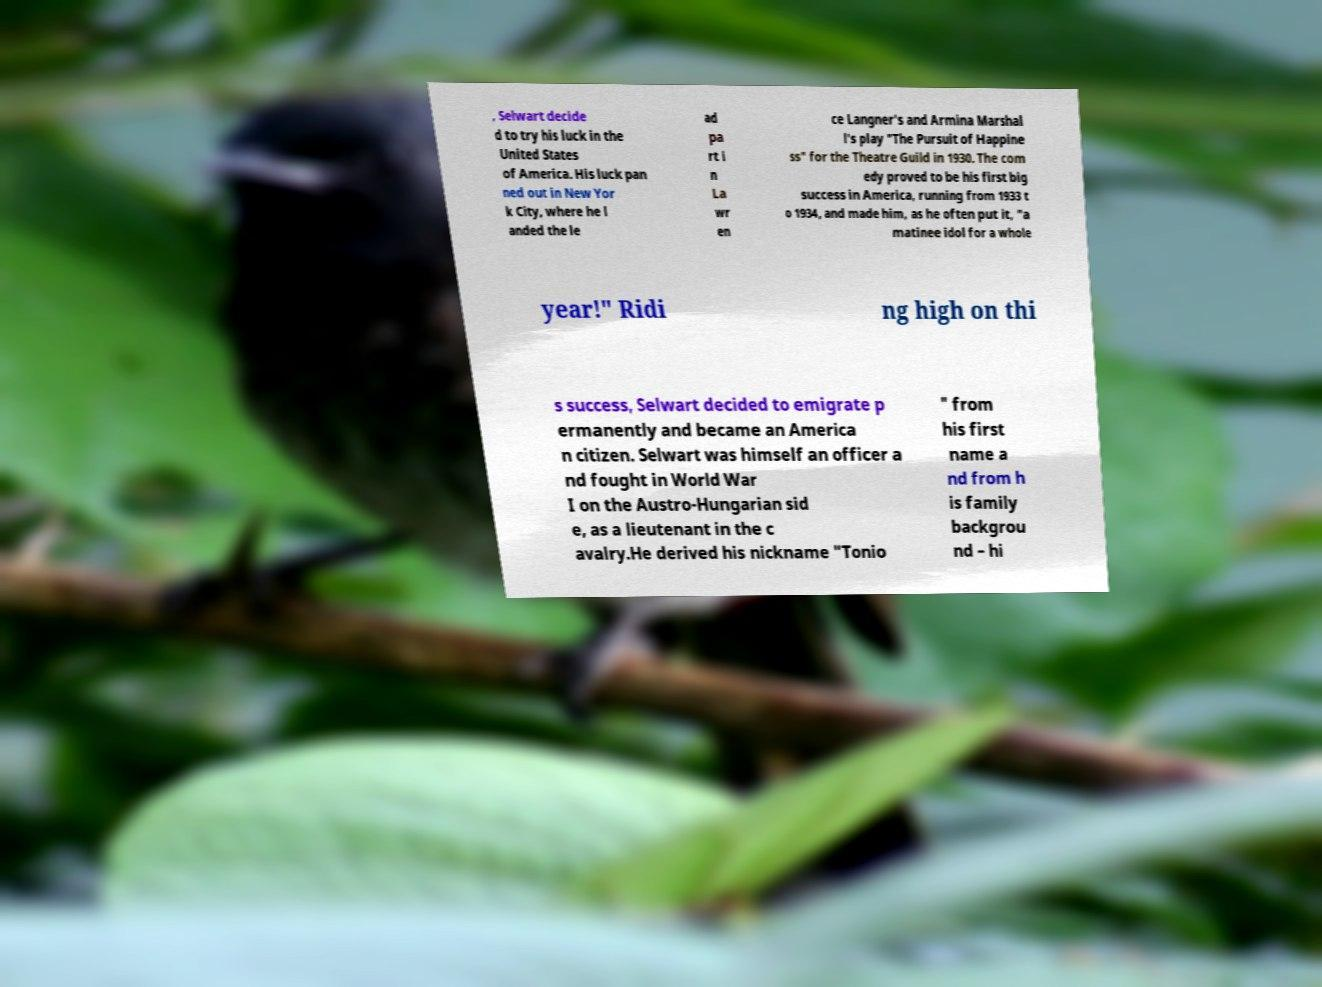There's text embedded in this image that I need extracted. Can you transcribe it verbatim? , Selwart decide d to try his luck in the United States of America. His luck pan ned out in New Yor k City, where he l anded the le ad pa rt i n La wr en ce Langner's and Armina Marshal l's play "The Pursuit of Happine ss" for the Theatre Guild in 1930. The com edy proved to be his first big success in America, running from 1933 t o 1934, and made him, as he often put it, "a matinee idol for a whole year!" Ridi ng high on thi s success, Selwart decided to emigrate p ermanently and became an America n citizen. Selwart was himself an officer a nd fought in World War I on the Austro-Hungarian sid e, as a lieutenant in the c avalry.He derived his nickname "Tonio " from his first name a nd from h is family backgrou nd – hi 